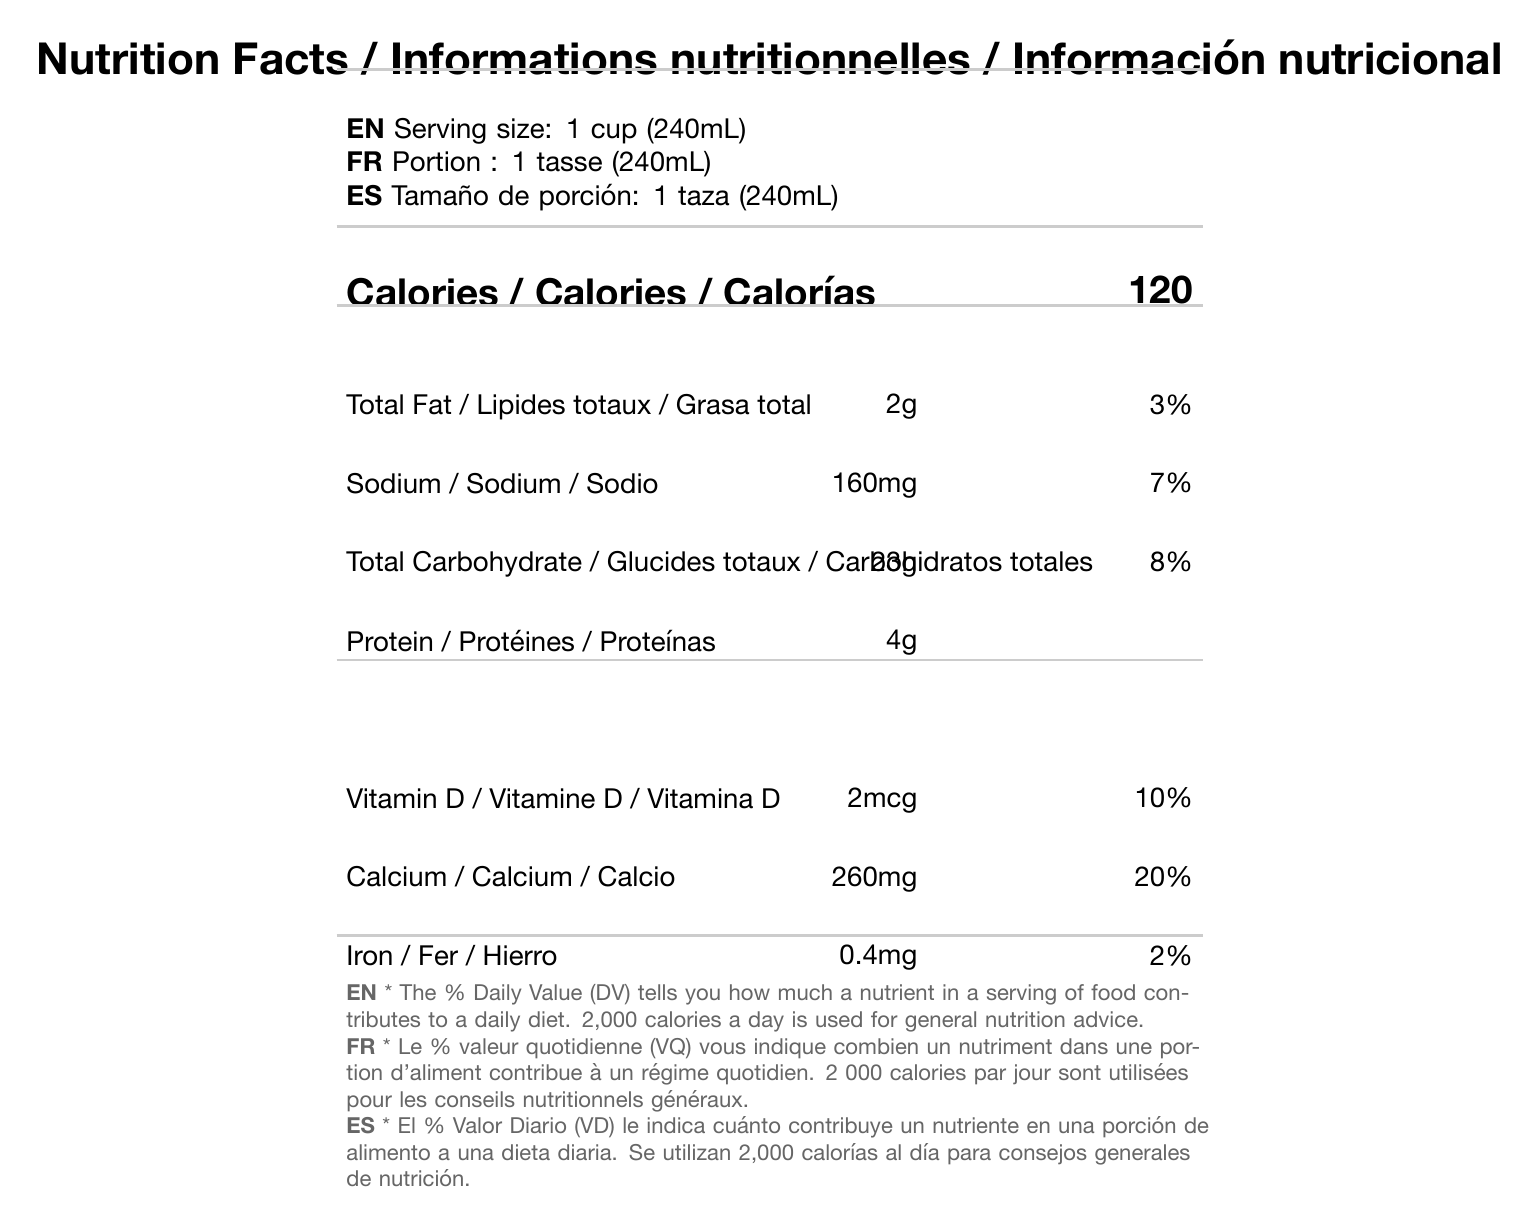what is the serving size in English? The serving size in English can be found under the "Serving size" section, labeled with "EN," which states "Serving size: 1 cup (240mL)."
Answer: 1 cup (240mL) what is the daily value percentage for sodium? The daily value percentage for sodium is listed as "7%" in the row where sodium is mentioned.
Answer: 7% in which languages is "Nutrition Facts" labeled at the top of the document? The label "Nutrition Facts" is displayed in English, French ("Informations nutritionnelles"), and Spanish ("Información nutricional").
Answer: English, French, Spanish what is the total fat content per serving? The total fat content per serving is found in the "Total Fat" row, which indicates "2g."
Answer: 2g what nutrient has the highest daily value percentage? The nutrient with the highest daily value percentage is calcium, which has a daily value of 20%.
Answer: Calcium what is the font size used for the footnote text? The footnote text is displayed in a font size of 8pt as specified in the typography guidelines.
Answer: 8pt what is the color scheme for the labels and background? A. Red and White B. Black and White C. Blue and White The document specifies the color scheme with primary color "#000000" (black), secondary color "#666666" (grey), and background color "#FFFFFF" (white).
Answer: B. Black and White which of the following nutrients does not have a daily value percentage listed? I. Total Carbohydrate II. Protein III. Vitamin D The row for "Protein" does not have a daily value percentage listed, while "Total Carbohydrate" and "Vitamin D" do.
Answer: II. Protein are all nutrients listed with their corresponding daily values? Not all nutrients have corresponding daily values listed. For example, "Protein" does not have a daily value percentage.
Answer: No what is the main idea of the document? The document is a multilingual Nutrition Facts Label featuring nutritional information on serving size, calories, macronutrients, and vitamins, formatted with clear typography guidelines to ensure legibility in English, French, and Spanish.
Answer: The document is a Nutrition Facts Label that presents nutritional information for a product in three languages (English, French, and Spanish), with specific attention to typography guidelines to ensure legibility and effective communication. what is the recommended daily calorie intake mentioned in the footnote? The footnote section mentions that "2,000 calories a day is used for general nutrition advice."
Answer: 2,000 calories how much iron is in one serving of the product? The iron content is listed as 0.4mg in the document under the "Iron" row.
Answer: 0.4mg what font is used for the primary text in the document? The primary font specified in the typography guidelines is "Helvetica Neue."
Answer: Helvetica Neue what is the daily value percentage for Vitamin D? The daily value percentage for Vitamin D is listed as 10% in the "Vitamin D" row.
Answer: 10% can you find ingredient details in the document? The document does not include any ingredient details; it only provides nutritional information.
Answer: Not enough information which nutrient's daily value is represented as "20%"? Calcium's daily value is represented as "20%" in the "Calcium" row.
Answer: Calcium how many languages does this Nutrition Facts Label accommodate? The Nutrition Facts Label accommodates three languages: English, French, and Spanish.
Answer: 3 